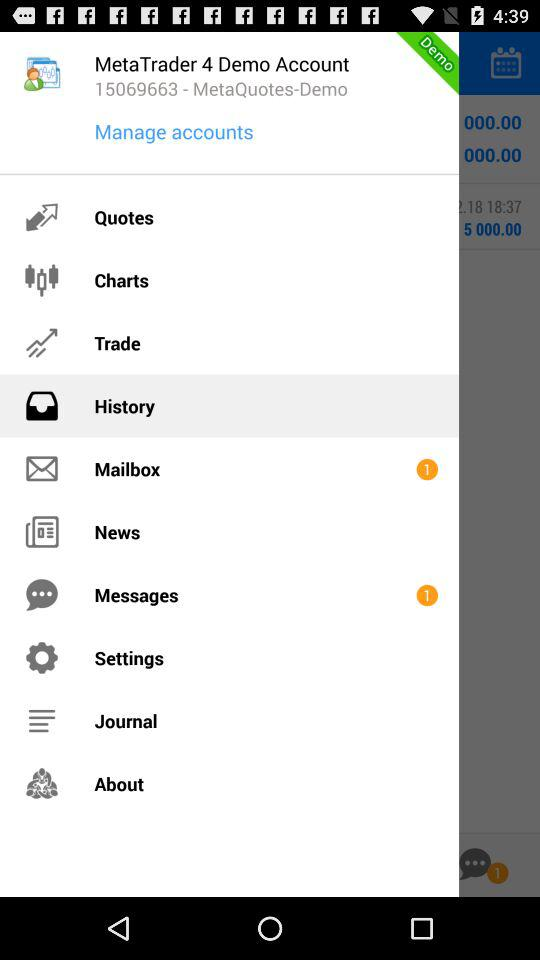How many unread messages are there? There is 1 unread message. 